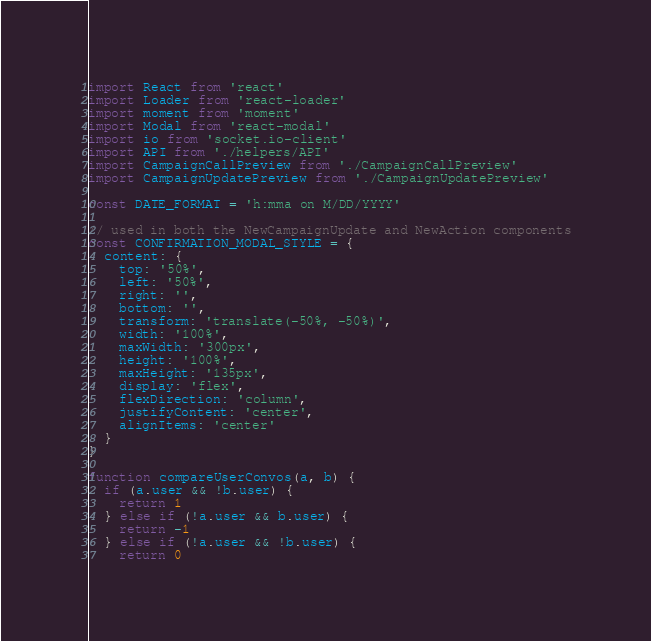Convert code to text. <code><loc_0><loc_0><loc_500><loc_500><_JavaScript_>import React from 'react'
import Loader from 'react-loader'
import moment from 'moment'
import Modal from 'react-modal'
import io from 'socket.io-client'
import API from './helpers/API'
import CampaignCallPreview from './CampaignCallPreview'
import CampaignUpdatePreview from './CampaignUpdatePreview'

const DATE_FORMAT = 'h:mma on M/DD/YYYY'

// used in both the NewCampaignUpdate and NewAction components
const CONFIRMATION_MODAL_STYLE = {
  content: {
    top: '50%',
    left: '50%',
    right: '',
    bottom: '',
    transform: 'translate(-50%, -50%)',
    width: '100%',
    maxWidth: '300px',
    height: '100%',
    maxHeight: '135px',
    display: 'flex',
    flexDirection: 'column',
    justifyContent: 'center',
    alignItems: 'center'
  }
}

function compareUserConvos(a, b) {
  if (a.user && !b.user) {
    return 1
  } else if (!a.user && b.user) {
    return -1
  } else if (!a.user && !b.user) {
    return 0</code> 